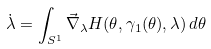Convert formula to latex. <formula><loc_0><loc_0><loc_500><loc_500>\dot { \lambda } = \int _ { S ^ { 1 } } \vec { \nabla } _ { \lambda } H ( \theta , \gamma _ { 1 } ( \theta ) , \lambda ) \, d \theta</formula> 